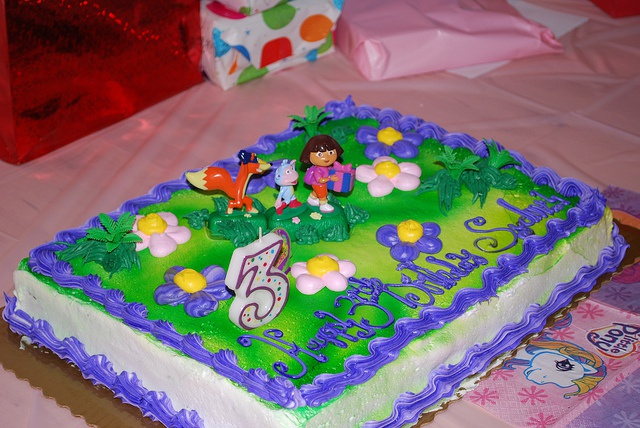Describe the objects in this image and their specific colors. I can see dining table in maroon, brown, darkgray, green, and blue tones and cake in maroon, green, blue, and lightgray tones in this image. 